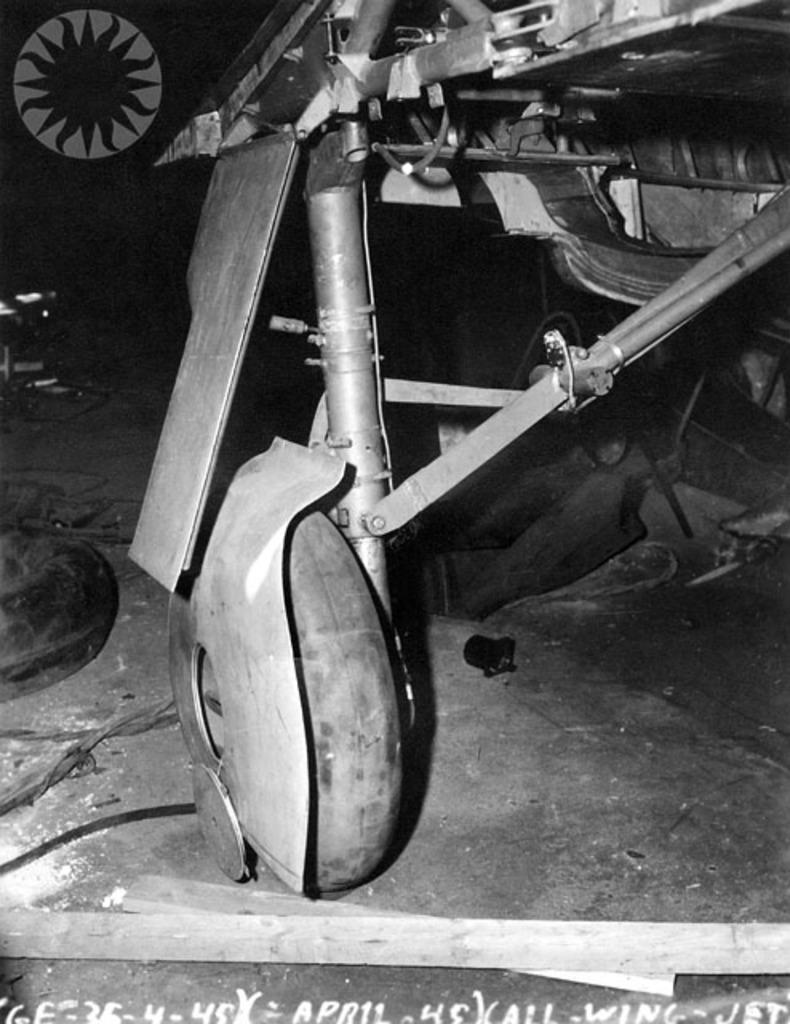In one or two sentences, can you explain what this image depicts? I see this is a black and white image and on this paper I see numbers and words written and I see a thing over here and there is a wheel connected to this thing and I see the ground on which there are few more things. 